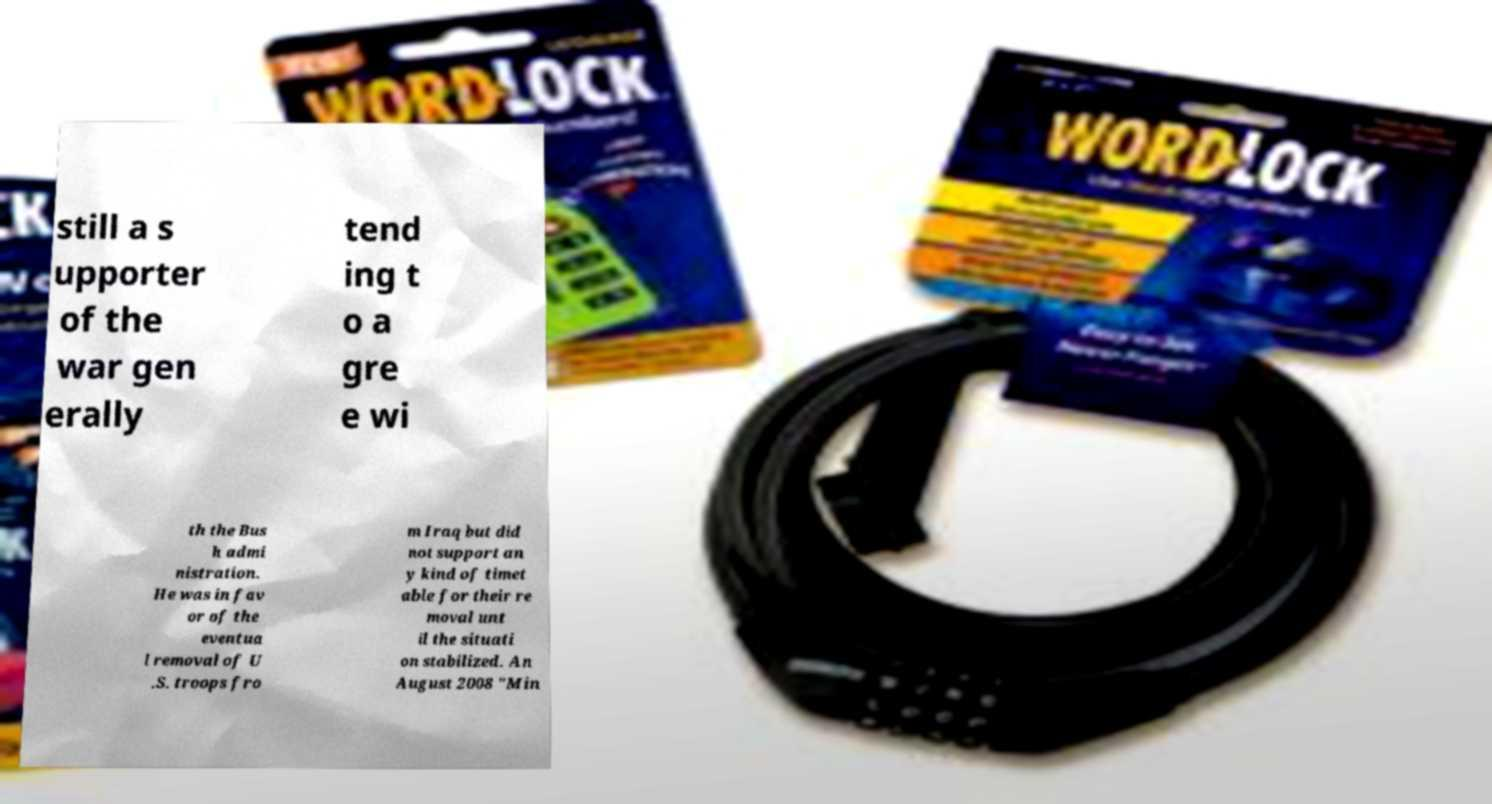Please identify and transcribe the text found in this image. still a s upporter of the war gen erally tend ing t o a gre e wi th the Bus h admi nistration. He was in fav or of the eventua l removal of U .S. troops fro m Iraq but did not support an y kind of timet able for their re moval unt il the situati on stabilized. An August 2008 "Min 